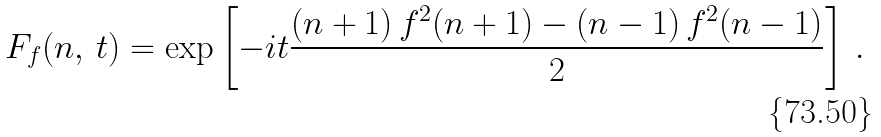Convert formula to latex. <formula><loc_0><loc_0><loc_500><loc_500>F _ { f } ( n , \, t ) = \exp \left [ - i t \frac { ( n + 1 ) \, f ^ { 2 } ( n + 1 ) - ( n - 1 ) \, f ^ { 2 } ( n - 1 ) } { 2 } \right ] \, .</formula> 